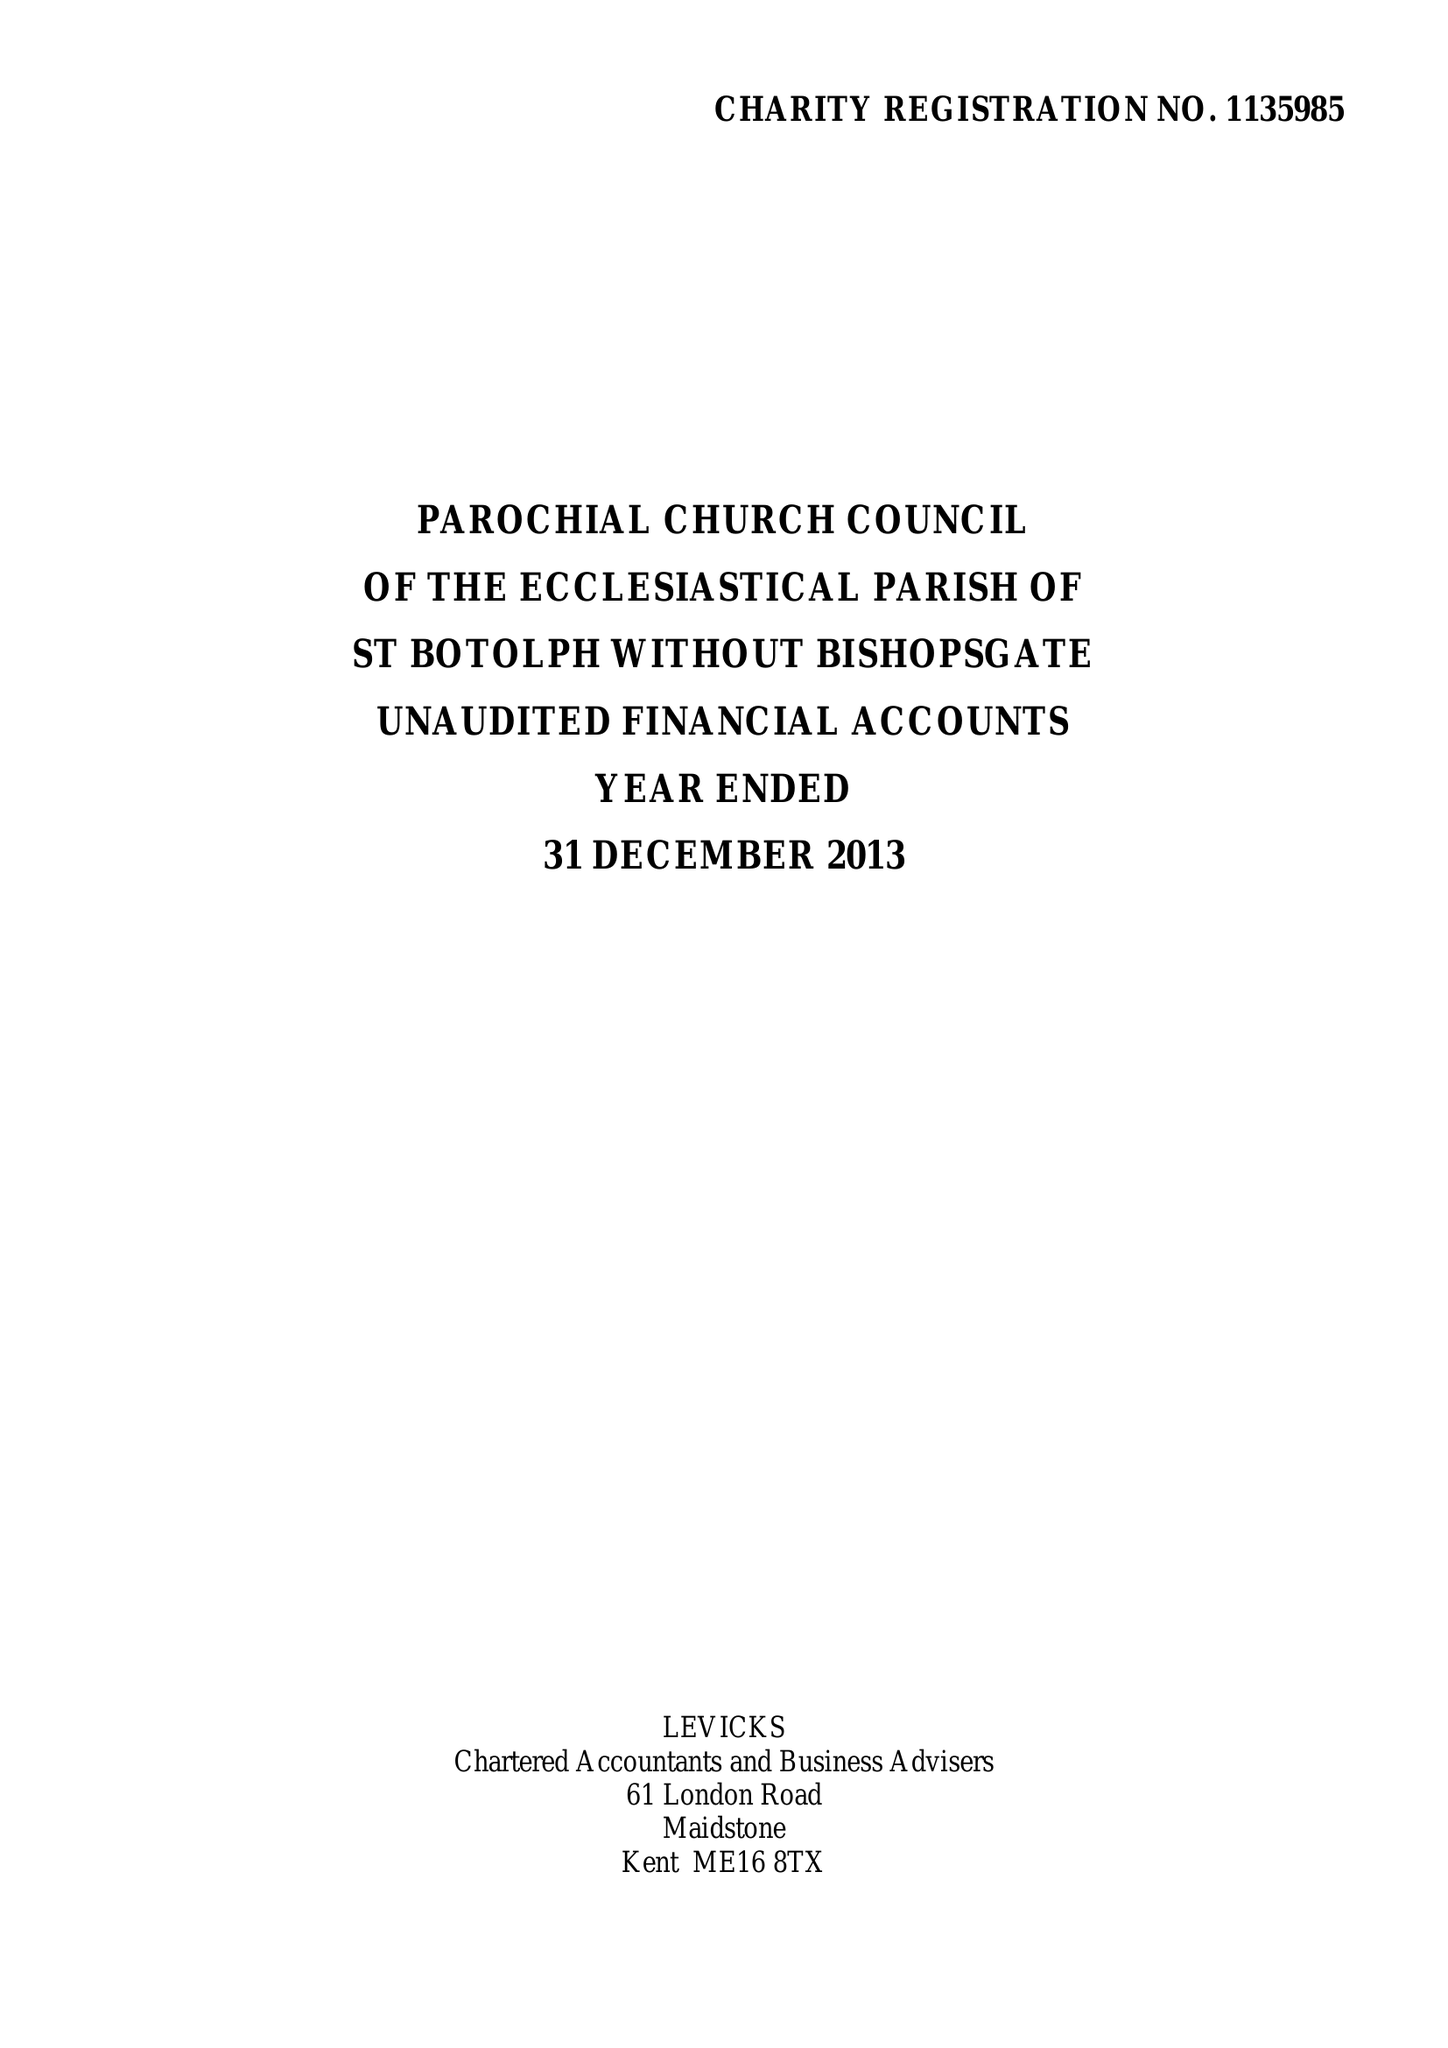What is the value for the report_date?
Answer the question using a single word or phrase. 2013-12-31 